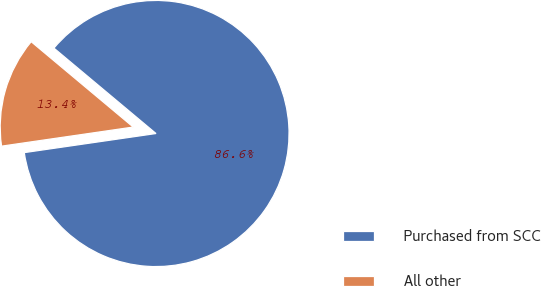<chart> <loc_0><loc_0><loc_500><loc_500><pie_chart><fcel>Purchased from SCC<fcel>All other<nl><fcel>86.62%<fcel>13.38%<nl></chart> 